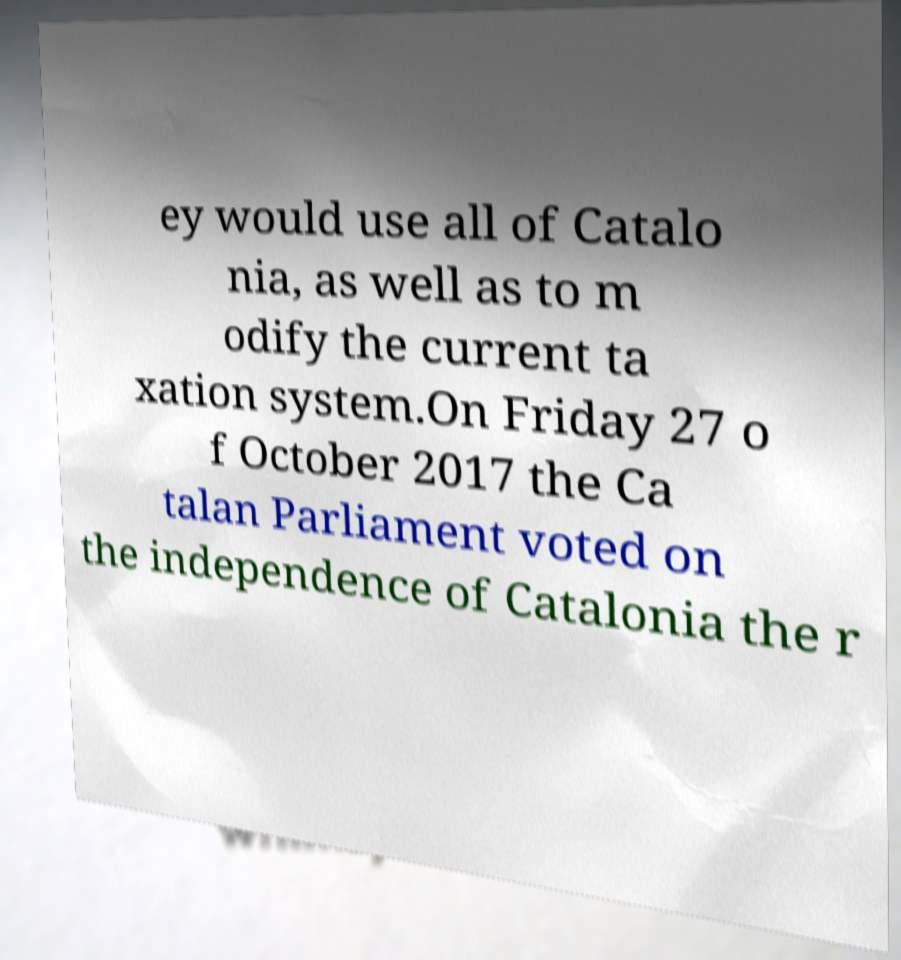What messages or text are displayed in this image? I need them in a readable, typed format. ey would use all of Catalo nia, as well as to m odify the current ta xation system.On Friday 27 o f October 2017 the Ca talan Parliament voted on the independence of Catalonia the r 